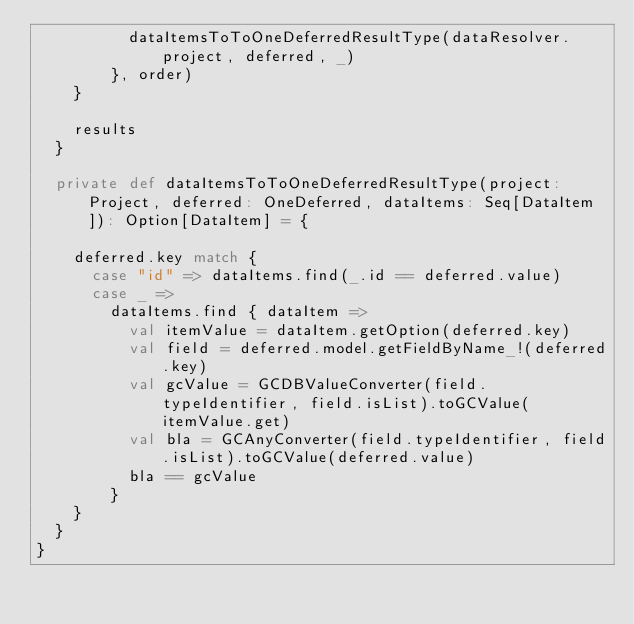Convert code to text. <code><loc_0><loc_0><loc_500><loc_500><_Scala_>          dataItemsToToOneDeferredResultType(dataResolver.project, deferred, _)
        }, order)
    }

    results
  }

  private def dataItemsToToOneDeferredResultType(project: Project, deferred: OneDeferred, dataItems: Seq[DataItem]): Option[DataItem] = {

    deferred.key match {
      case "id" => dataItems.find(_.id == deferred.value)
      case _ =>
        dataItems.find { dataItem =>
          val itemValue = dataItem.getOption(deferred.key)
          val field = deferred.model.getFieldByName_!(deferred.key)
          val gcValue = GCDBValueConverter(field.typeIdentifier, field.isList).toGCValue(itemValue.get)
          val bla = GCAnyConverter(field.typeIdentifier, field.isList).toGCValue(deferred.value)
          bla == gcValue
        }
    }
  }
}
</code> 